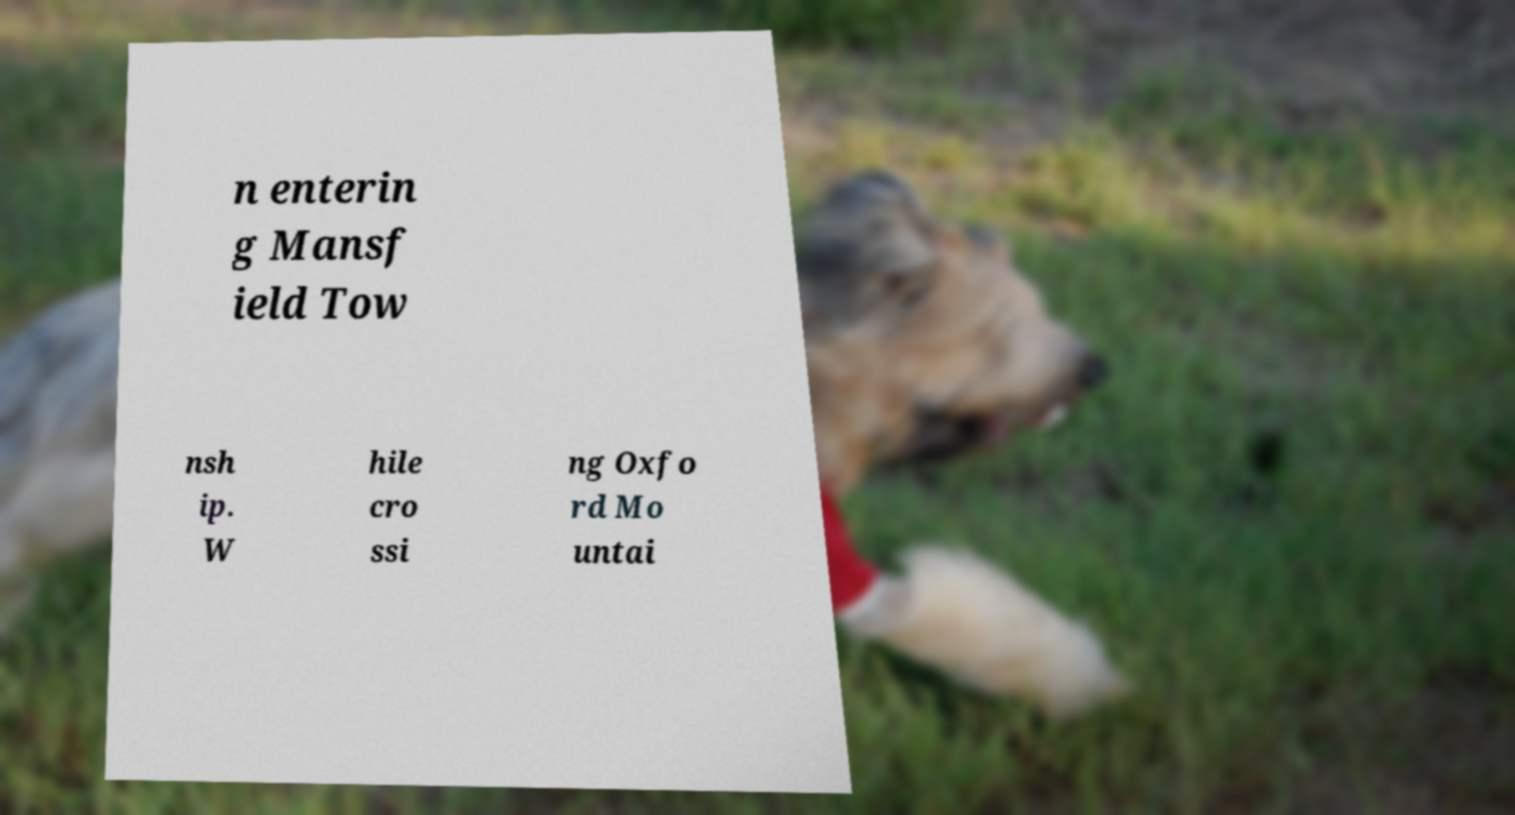I need the written content from this picture converted into text. Can you do that? n enterin g Mansf ield Tow nsh ip. W hile cro ssi ng Oxfo rd Mo untai 